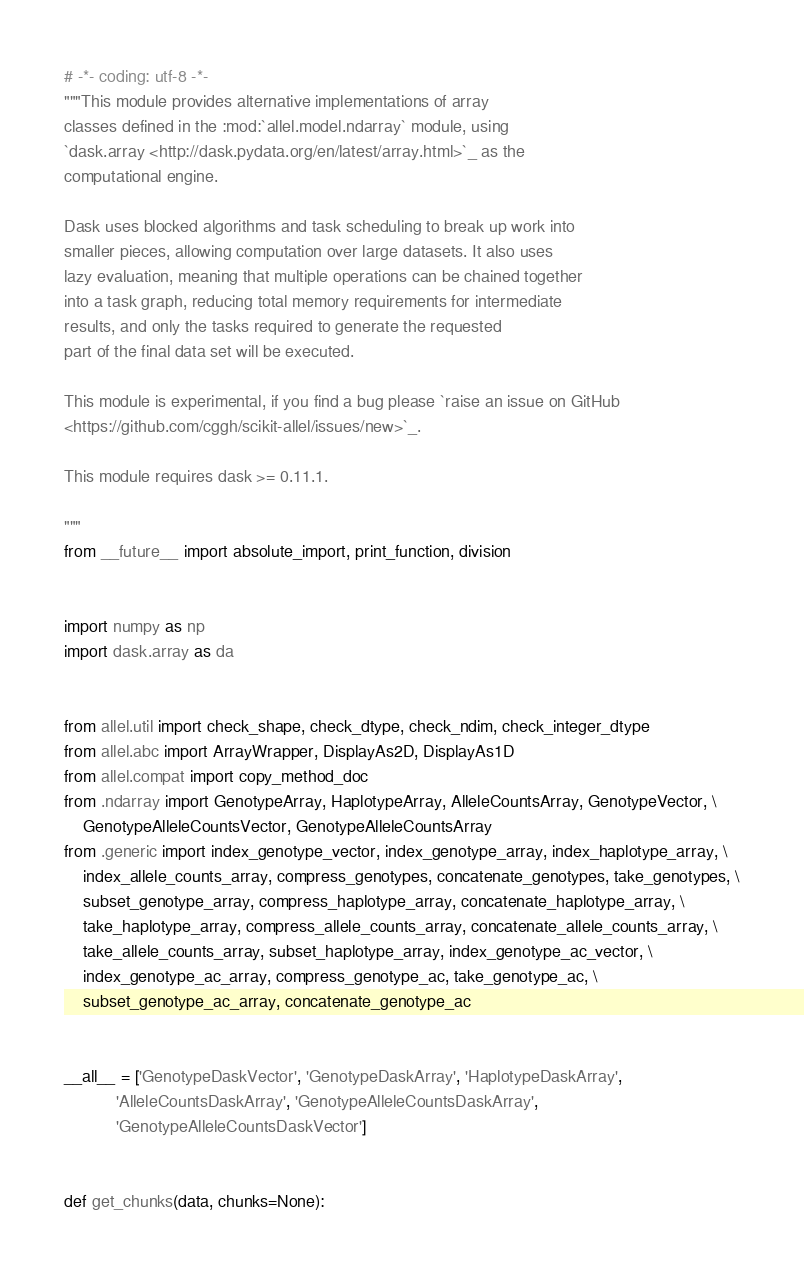<code> <loc_0><loc_0><loc_500><loc_500><_Python_># -*- coding: utf-8 -*-
"""This module provides alternative implementations of array
classes defined in the :mod:`allel.model.ndarray` module, using
`dask.array <http://dask.pydata.org/en/latest/array.html>`_ as the
computational engine.

Dask uses blocked algorithms and task scheduling to break up work into
smaller pieces, allowing computation over large datasets. It also uses
lazy evaluation, meaning that multiple operations can be chained together
into a task graph, reducing total memory requirements for intermediate
results, and only the tasks required to generate the requested
part of the final data set will be executed.

This module is experimental, if you find a bug please `raise an issue on GitHub
<https://github.com/cggh/scikit-allel/issues/new>`_.

This module requires dask >= 0.11.1.

"""
from __future__ import absolute_import, print_function, division


import numpy as np
import dask.array as da


from allel.util import check_shape, check_dtype, check_ndim, check_integer_dtype
from allel.abc import ArrayWrapper, DisplayAs2D, DisplayAs1D
from allel.compat import copy_method_doc
from .ndarray import GenotypeArray, HaplotypeArray, AlleleCountsArray, GenotypeVector, \
    GenotypeAlleleCountsVector, GenotypeAlleleCountsArray
from .generic import index_genotype_vector, index_genotype_array, index_haplotype_array, \
    index_allele_counts_array, compress_genotypes, concatenate_genotypes, take_genotypes, \
    subset_genotype_array, compress_haplotype_array, concatenate_haplotype_array, \
    take_haplotype_array, compress_allele_counts_array, concatenate_allele_counts_array, \
    take_allele_counts_array, subset_haplotype_array, index_genotype_ac_vector, \
    index_genotype_ac_array, compress_genotype_ac, take_genotype_ac, \
    subset_genotype_ac_array, concatenate_genotype_ac


__all__ = ['GenotypeDaskVector', 'GenotypeDaskArray', 'HaplotypeDaskArray',
           'AlleleCountsDaskArray', 'GenotypeAlleleCountsDaskArray',
           'GenotypeAlleleCountsDaskVector']


def get_chunks(data, chunks=None):</code> 